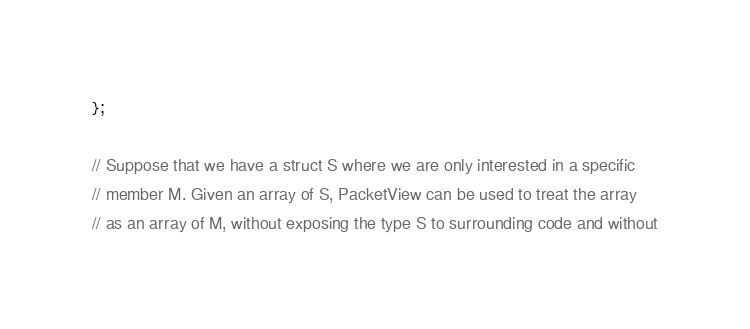<code> <loc_0><loc_0><loc_500><loc_500><_C_>};

// Suppose that we have a struct S where we are only interested in a specific
// member M. Given an array of S, PacketView can be used to treat the array
// as an array of M, without exposing the type S to surrounding code and without</code> 